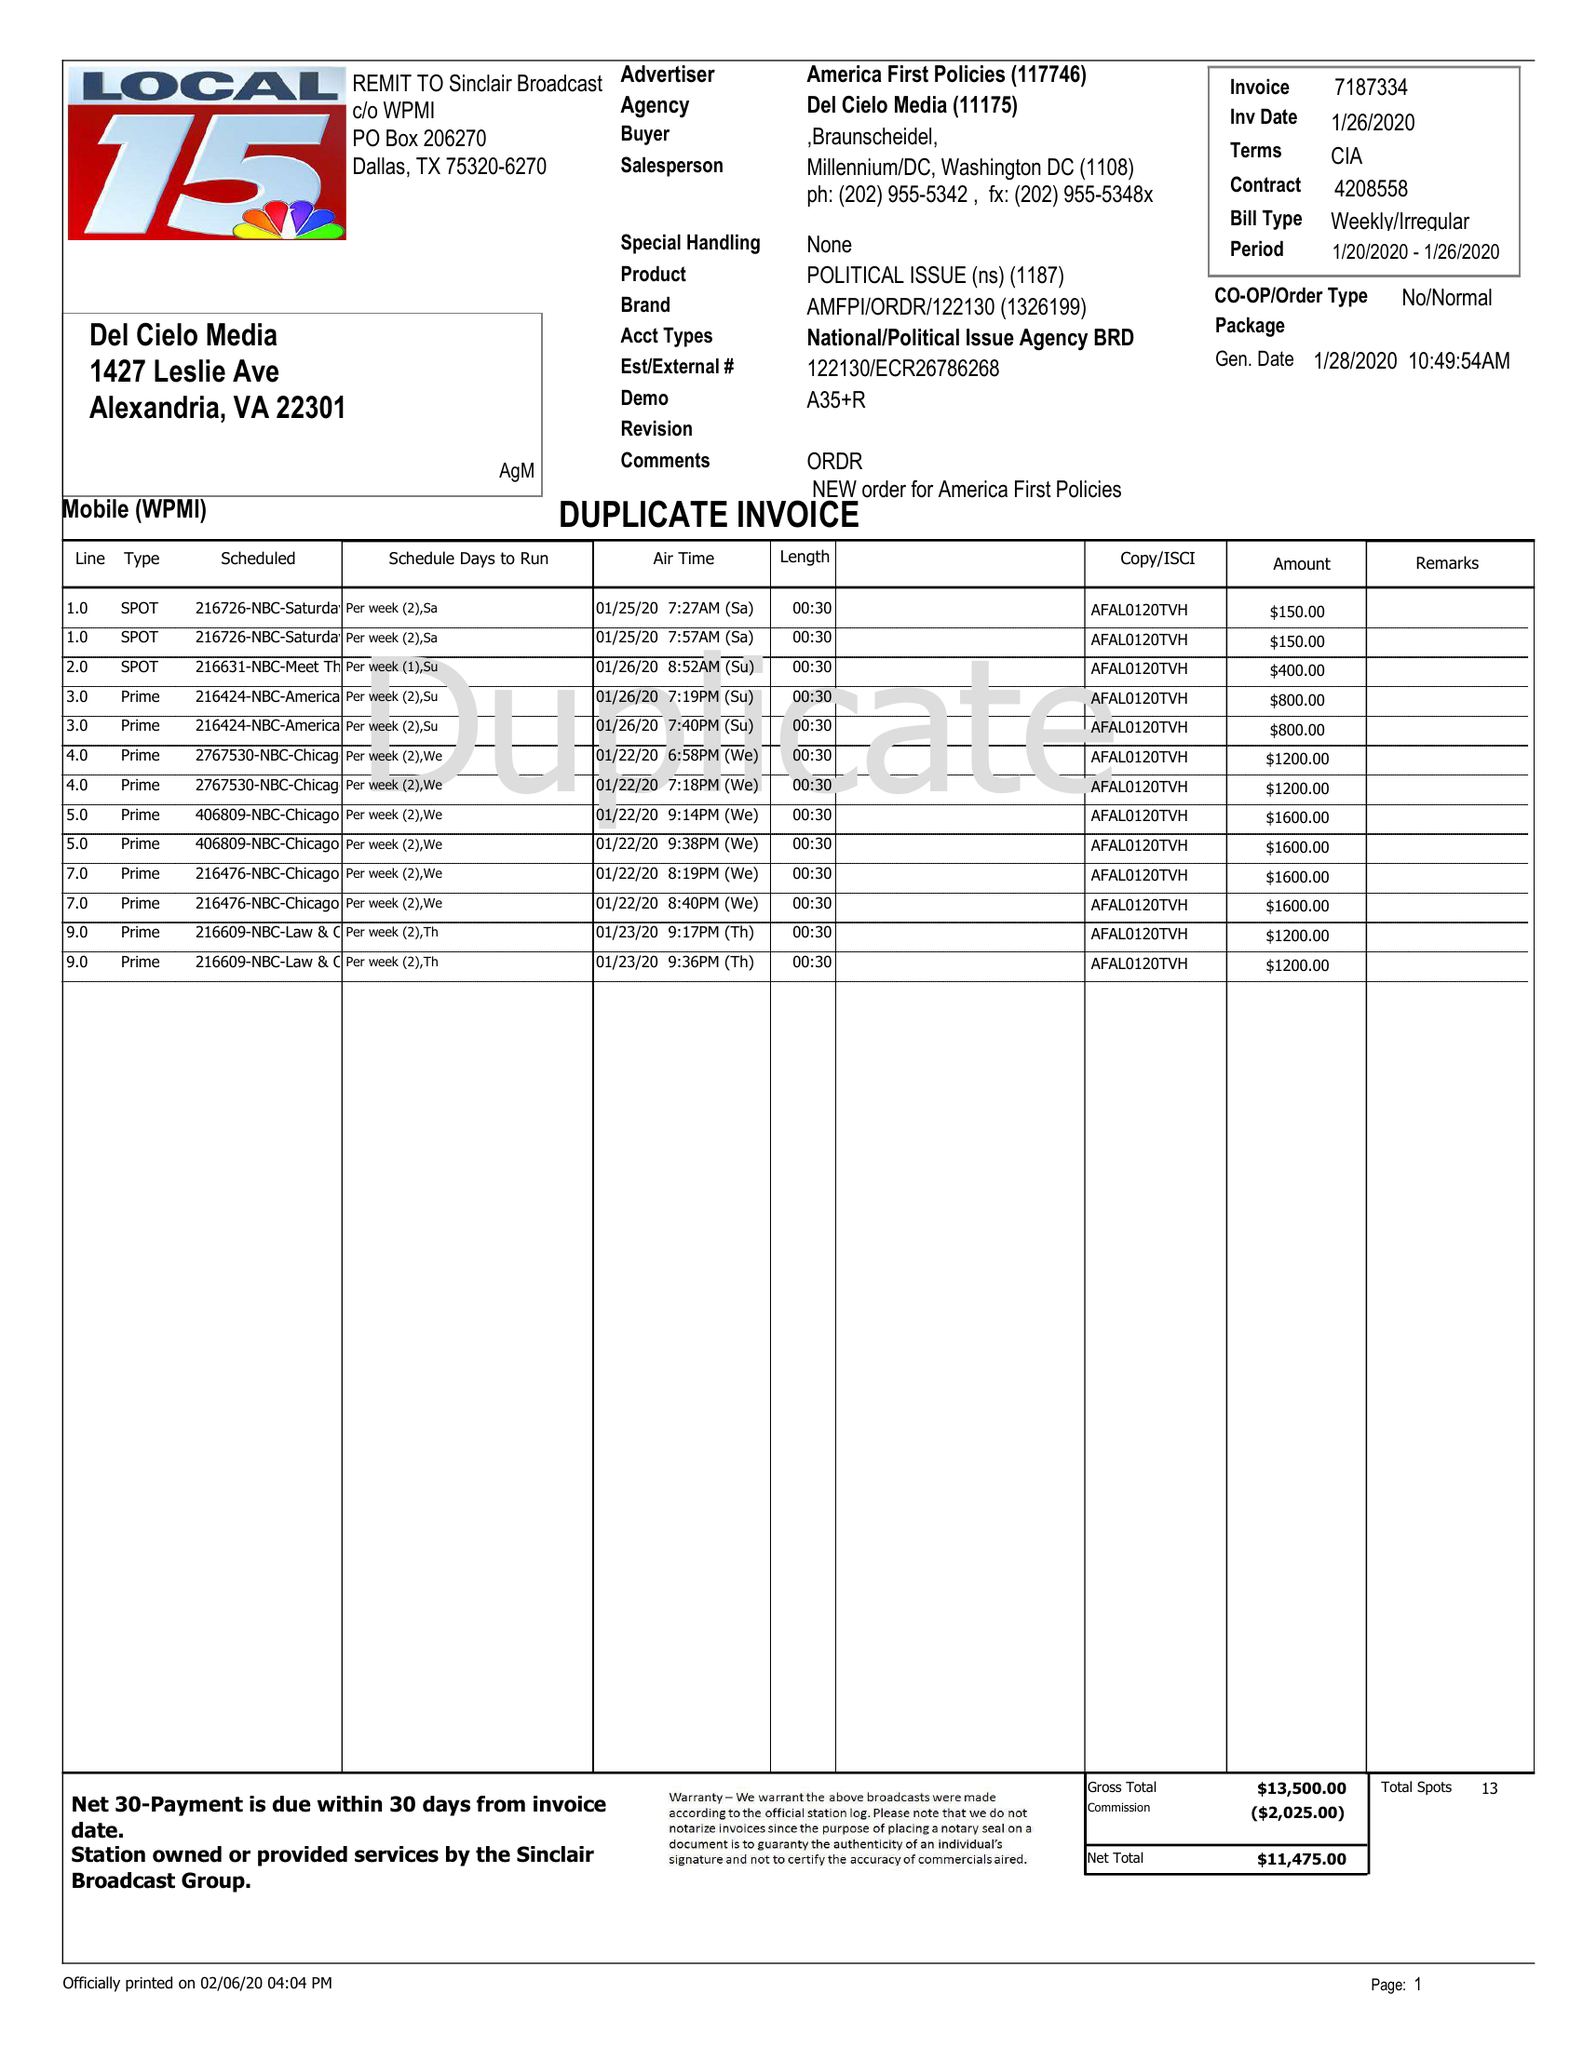What is the value for the flight_to?
Answer the question using a single word or phrase. 01/26/20 